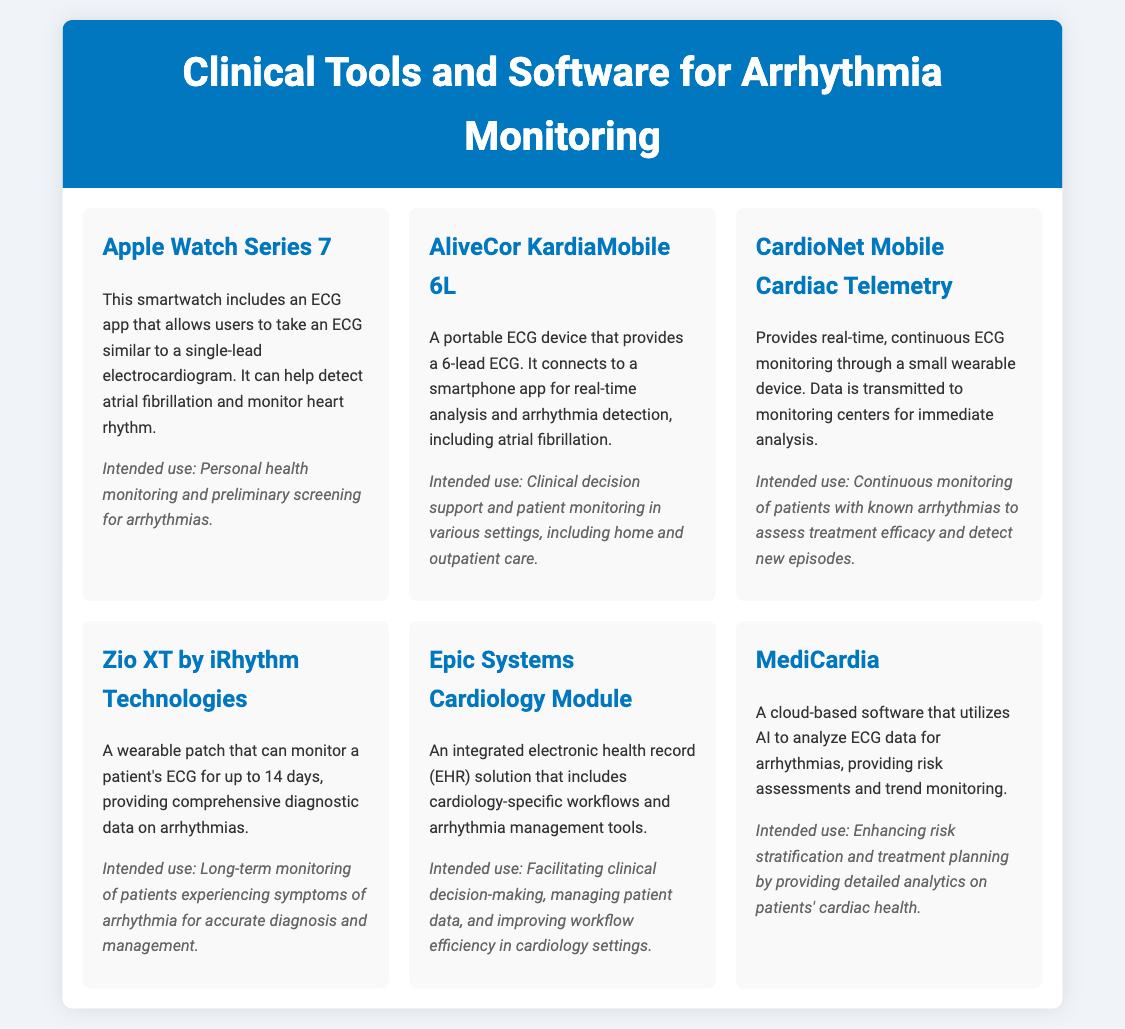What is the name of the portable ECG device? The portable ECG device is specifically identified in the document as "AliveCor KardiaMobile 6L."
Answer: AliveCor KardiaMobile 6L What is the intended use of the Apple Watch Series 7? The intended use for the Apple Watch Series 7, as mentioned in the document, is for personal health monitoring and preliminary screening for arrhythmias.
Answer: Personal health monitoring and preliminary screening for arrhythmias How long can the Zio XT monitor a patient's ECG? According to the document, the Zio XT can monitor a patient's ECG for up to 14 days.
Answer: 14 days What type of solution does the Epic Systems Cardiology Module provide? The Epic Systems Cardiology Module is described in the document as an integrated electronic health record (EHR) solution.
Answer: Integrated electronic health record (EHR) solution What kind of analysis does MediCardia utilize? MediCardia makes use of AI to analyze ECG data for arrhythmias, as stated in the document.
Answer: AI What feature distinguishes CardioNet Mobile Cardiac Telemetry? The distinguishing feature of CardioNet Mobile Cardiac Telemetry is its provision of real-time, continuous ECG monitoring through a small wearable device.
Answer: Real-time, continuous ECG monitoring Which device is intended for continuous monitoring of patients with known arrhythmias? The document specifies that CardioNet Mobile Cardiac Telemetry is intended for continuous monitoring of patients with known arrhythmias.
Answer: CardioNet Mobile Cardiac Telemetry What is the main purpose of AliveCor KardiaMobile 6L? The primary purpose of AliveCor KardiaMobile 6L, as indicated in the document, is clinical decision support and patient monitoring in various settings.
Answer: Clinical decision support and patient monitoring What does Zio XT provide for arrhythmias? The Zio XT provides comprehensive diagnostic data on arrhythmias, according to the document.
Answer: Comprehensive diagnostic data on arrhythmias 